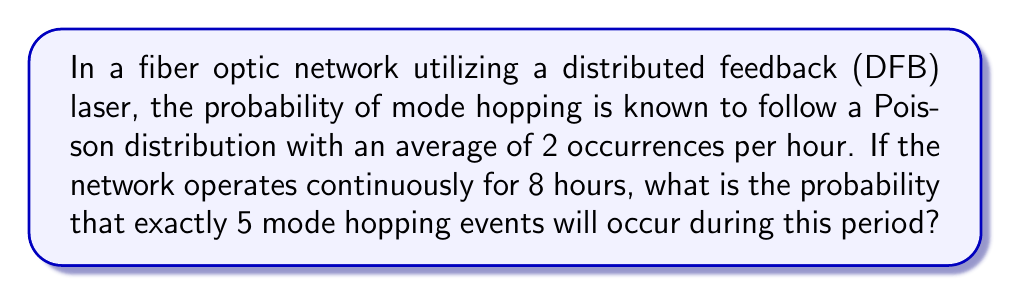Give your solution to this math problem. To solve this problem, we'll use the Poisson probability mass function:

$$P(X = k) = \frac{e^{-\lambda} \lambda^k}{k!}$$

Where:
$\lambda$ = average number of events in the given time period
$k$ = number of events we're interested in
$e$ = Euler's number (approximately 2.71828)

Steps:
1. Calculate $\lambda$ for the 8-hour period:
   $\lambda = 2 \text{ events/hour} \times 8 \text{ hours} = 16$

2. Substitute the values into the Poisson formula:
   $$P(X = 5) = \frac{e^{-16} 16^5}{5!}$$

3. Calculate the numerator:
   $e^{-16} \approx 1.125352 \times 10^{-7}$
   $16^5 = 1,048,576$
   $e^{-16} 16^5 \approx 0.1180$

4. Calculate the denominator:
   $5! = 5 \times 4 \times 3 \times 2 \times 1 = 120$

5. Divide the numerator by the denominator:
   $$P(X = 5) = \frac{0.1180}{120} \approx 0.000983$$

6. Convert to a percentage:
   $0.000983 \times 100\% \approx 0.0983\%$
Answer: $0.0983\%$ 